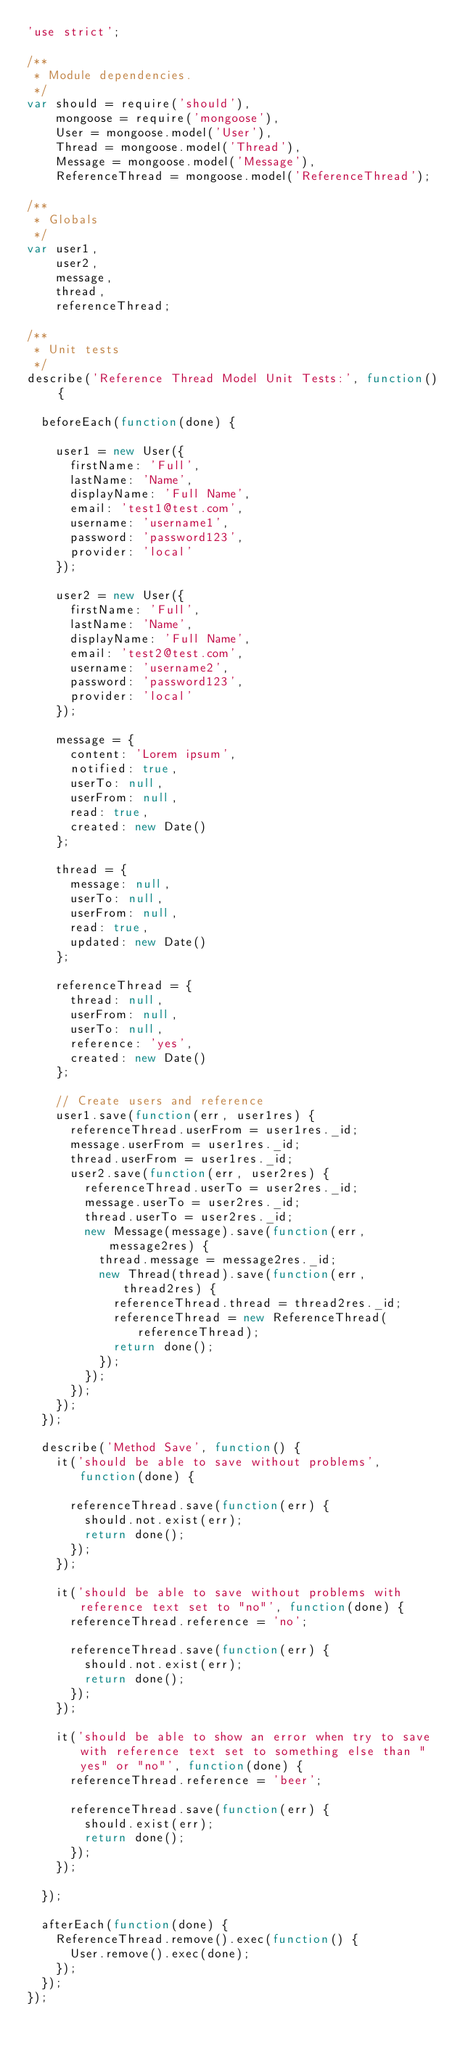Convert code to text. <code><loc_0><loc_0><loc_500><loc_500><_JavaScript_>'use strict';

/**
 * Module dependencies.
 */
var should = require('should'),
    mongoose = require('mongoose'),
    User = mongoose.model('User'),
    Thread = mongoose.model('Thread'),
    Message = mongoose.model('Message'),
    ReferenceThread = mongoose.model('ReferenceThread');

/**
 * Globals
 */
var user1,
    user2,
    message,
    thread,
    referenceThread;

/**
 * Unit tests
 */
describe('Reference Thread Model Unit Tests:', function() {

  beforeEach(function(done) {

    user1 = new User({
      firstName: 'Full',
      lastName: 'Name',
      displayName: 'Full Name',
      email: 'test1@test.com',
      username: 'username1',
      password: 'password123',
      provider: 'local'
    });

    user2 = new User({
      firstName: 'Full',
      lastName: 'Name',
      displayName: 'Full Name',
      email: 'test2@test.com',
      username: 'username2',
      password: 'password123',
      provider: 'local'
    });

    message = {
      content: 'Lorem ipsum',
      notified: true,
      userTo: null,
      userFrom: null,
      read: true,
      created: new Date()
    };

    thread = {
      message: null,
      userTo: null,
      userFrom: null,
      read: true,
      updated: new Date()
    };

    referenceThread = {
      thread: null,
      userFrom: null,
      userTo: null,
      reference: 'yes',
      created: new Date()
    };

    // Create users and reference
    user1.save(function(err, user1res) {
      referenceThread.userFrom = user1res._id;
      message.userFrom = user1res._id;
      thread.userFrom = user1res._id;
      user2.save(function(err, user2res) {
        referenceThread.userTo = user2res._id;
        message.userTo = user2res._id;
        thread.userTo = user2res._id;
        new Message(message).save(function(err, message2res) {
          thread.message = message2res._id;
          new Thread(thread).save(function(err, thread2res) {
            referenceThread.thread = thread2res._id;
            referenceThread = new ReferenceThread(referenceThread);
            return done();
          });
        });
      });
    });
  });

  describe('Method Save', function() {
    it('should be able to save without problems', function(done) {

      referenceThread.save(function(err) {
        should.not.exist(err);
        return done();
      });
    });

    it('should be able to save without problems with reference text set to "no"', function(done) {
      referenceThread.reference = 'no';

      referenceThread.save(function(err) {
        should.not.exist(err);
        return done();
      });
    });

    it('should be able to show an error when try to save with reference text set to something else than "yes" or "no"', function(done) {
      referenceThread.reference = 'beer';

      referenceThread.save(function(err) {
        should.exist(err);
        return done();
      });
    });

  });

  afterEach(function(done) {
    ReferenceThread.remove().exec(function() {
      User.remove().exec(done);
    });
  });
});
</code> 